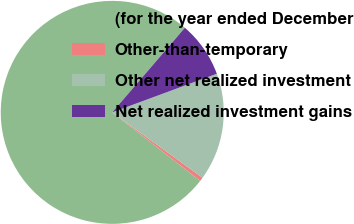Convert chart to OTSL. <chart><loc_0><loc_0><loc_500><loc_500><pie_chart><fcel>(for the year ended December<fcel>Other-than-temporary<fcel>Other net realized investment<fcel>Net realized investment gains<nl><fcel>75.75%<fcel>0.56%<fcel>15.6%<fcel>8.08%<nl></chart> 